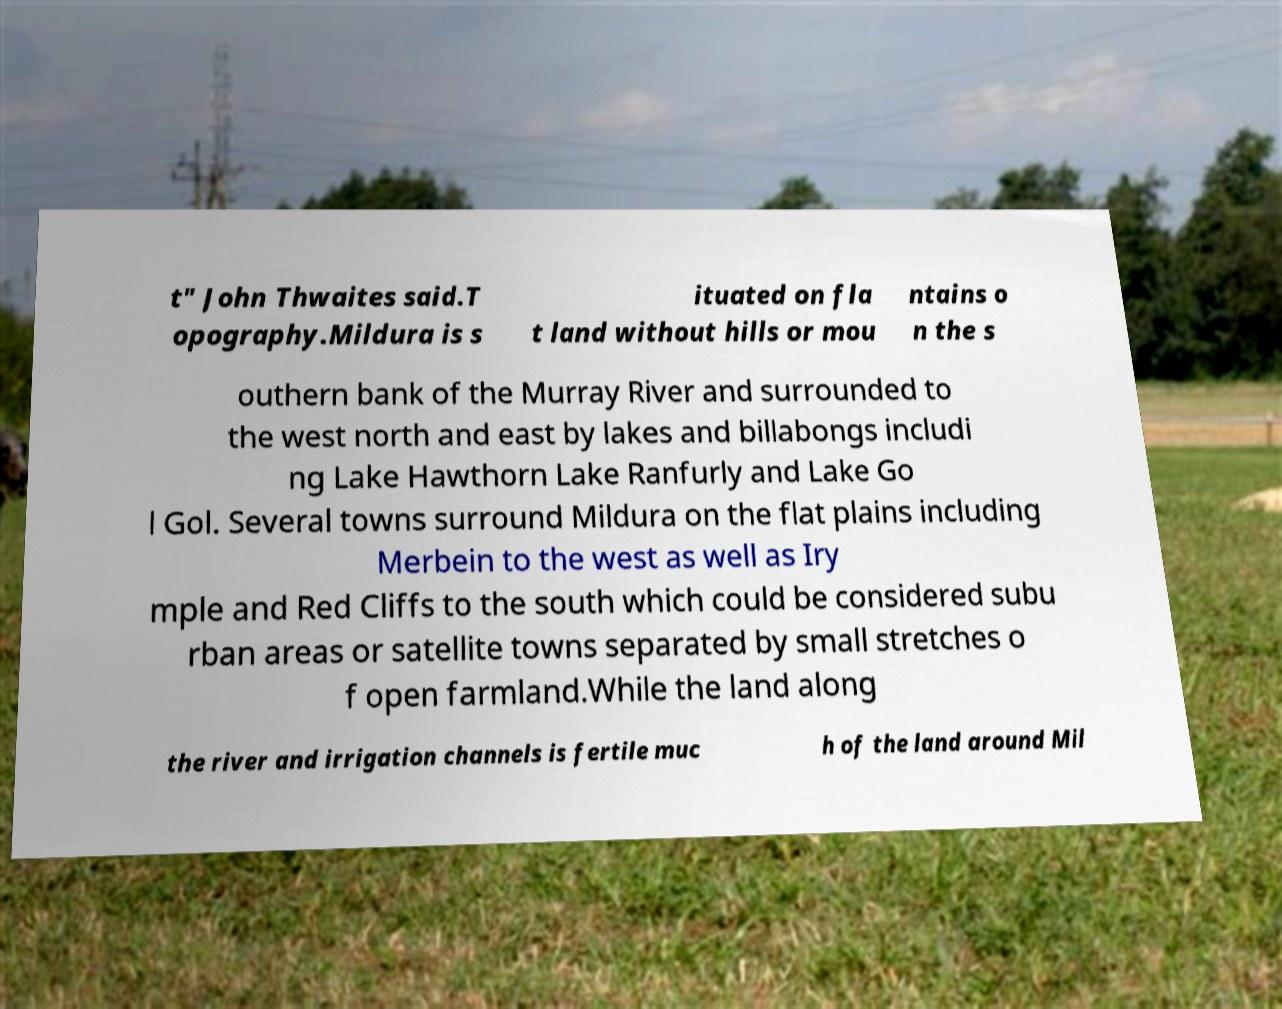Can you read and provide the text displayed in the image?This photo seems to have some interesting text. Can you extract and type it out for me? t" John Thwaites said.T opography.Mildura is s ituated on fla t land without hills or mou ntains o n the s outhern bank of the Murray River and surrounded to the west north and east by lakes and billabongs includi ng Lake Hawthorn Lake Ranfurly and Lake Go l Gol. Several towns surround Mildura on the flat plains including Merbein to the west as well as Iry mple and Red Cliffs to the south which could be considered subu rban areas or satellite towns separated by small stretches o f open farmland.While the land along the river and irrigation channels is fertile muc h of the land around Mil 